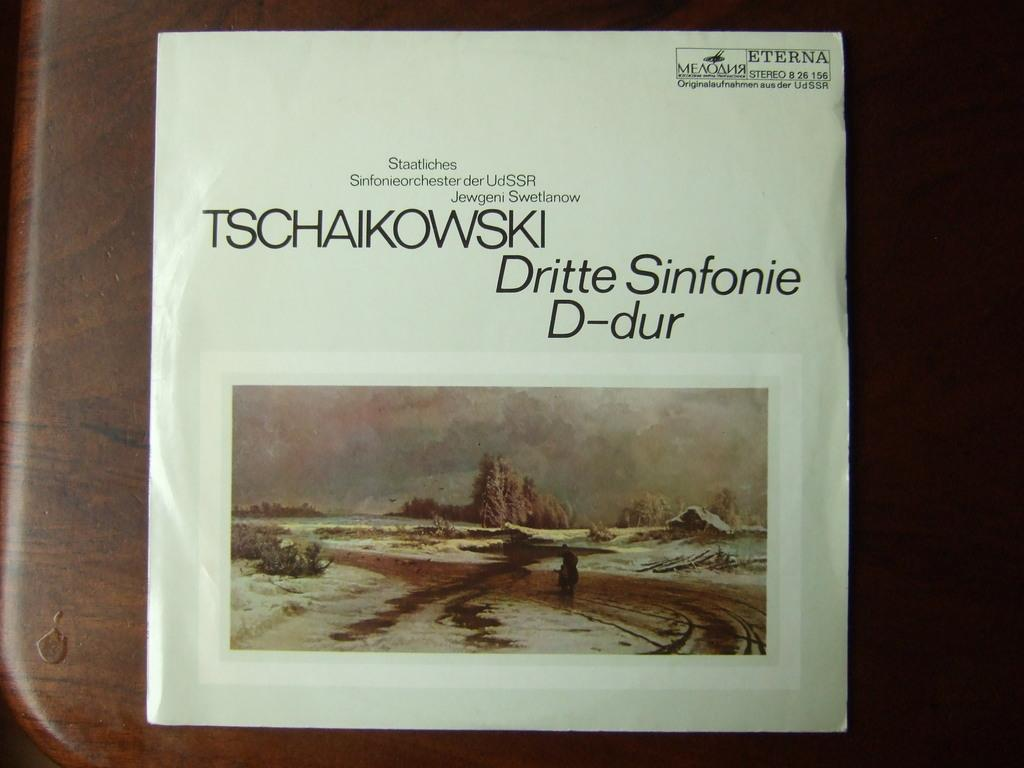<image>
Write a terse but informative summary of the picture. Tschaikowski's Dritte Sinfonie D-dur cover laying on a wooden table. 